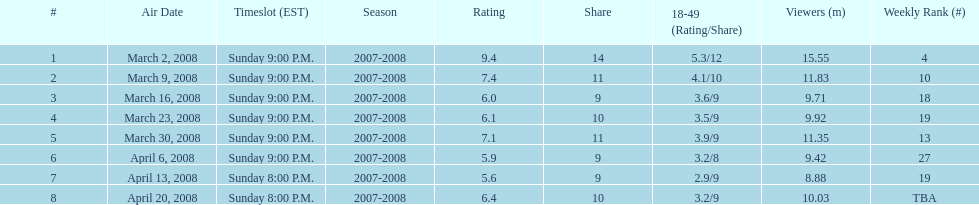Which show obtained the top rating? 1. 